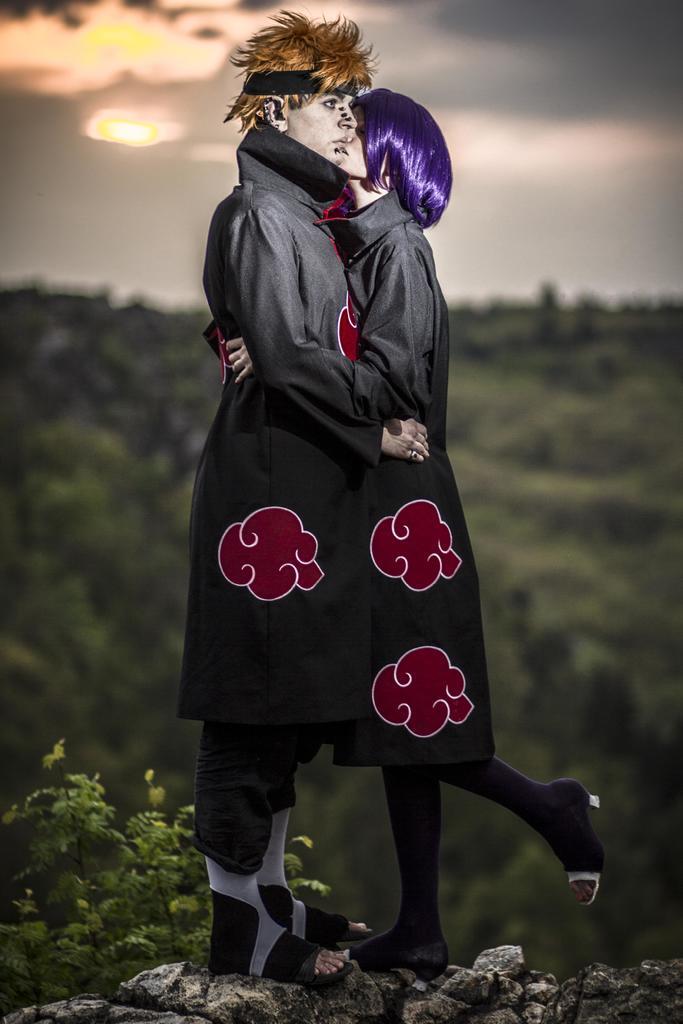Please provide a concise description of this image. In this picture I can see the depiction picture, where I can see a woman and a man standing in front and on the bottom left of this picture I can see the leaves and I see that it is totally blurred in the background and I see the cloudy sky on the top of this picture. 